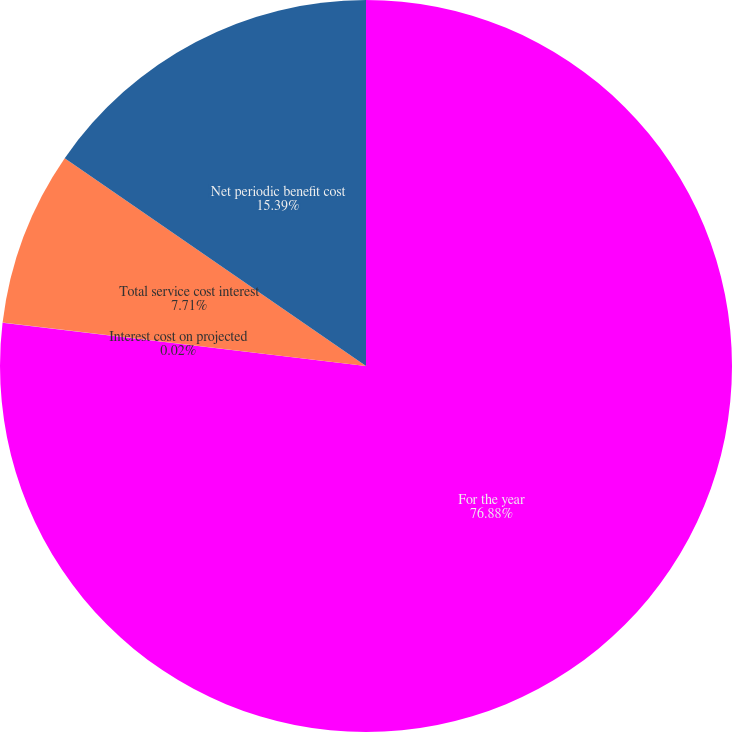Convert chart to OTSL. <chart><loc_0><loc_0><loc_500><loc_500><pie_chart><fcel>For the year<fcel>Interest cost on projected<fcel>Total service cost interest<fcel>Net periodic benefit cost<nl><fcel>76.88%<fcel>0.02%<fcel>7.71%<fcel>15.39%<nl></chart> 